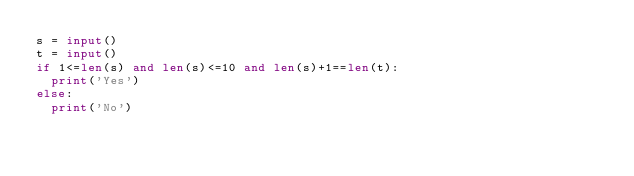Convert code to text. <code><loc_0><loc_0><loc_500><loc_500><_Python_>s = input()
t = input()
if 1<=len(s) and len(s)<=10 and len(s)+1==len(t):
  print('Yes')
else:
  print('No')</code> 